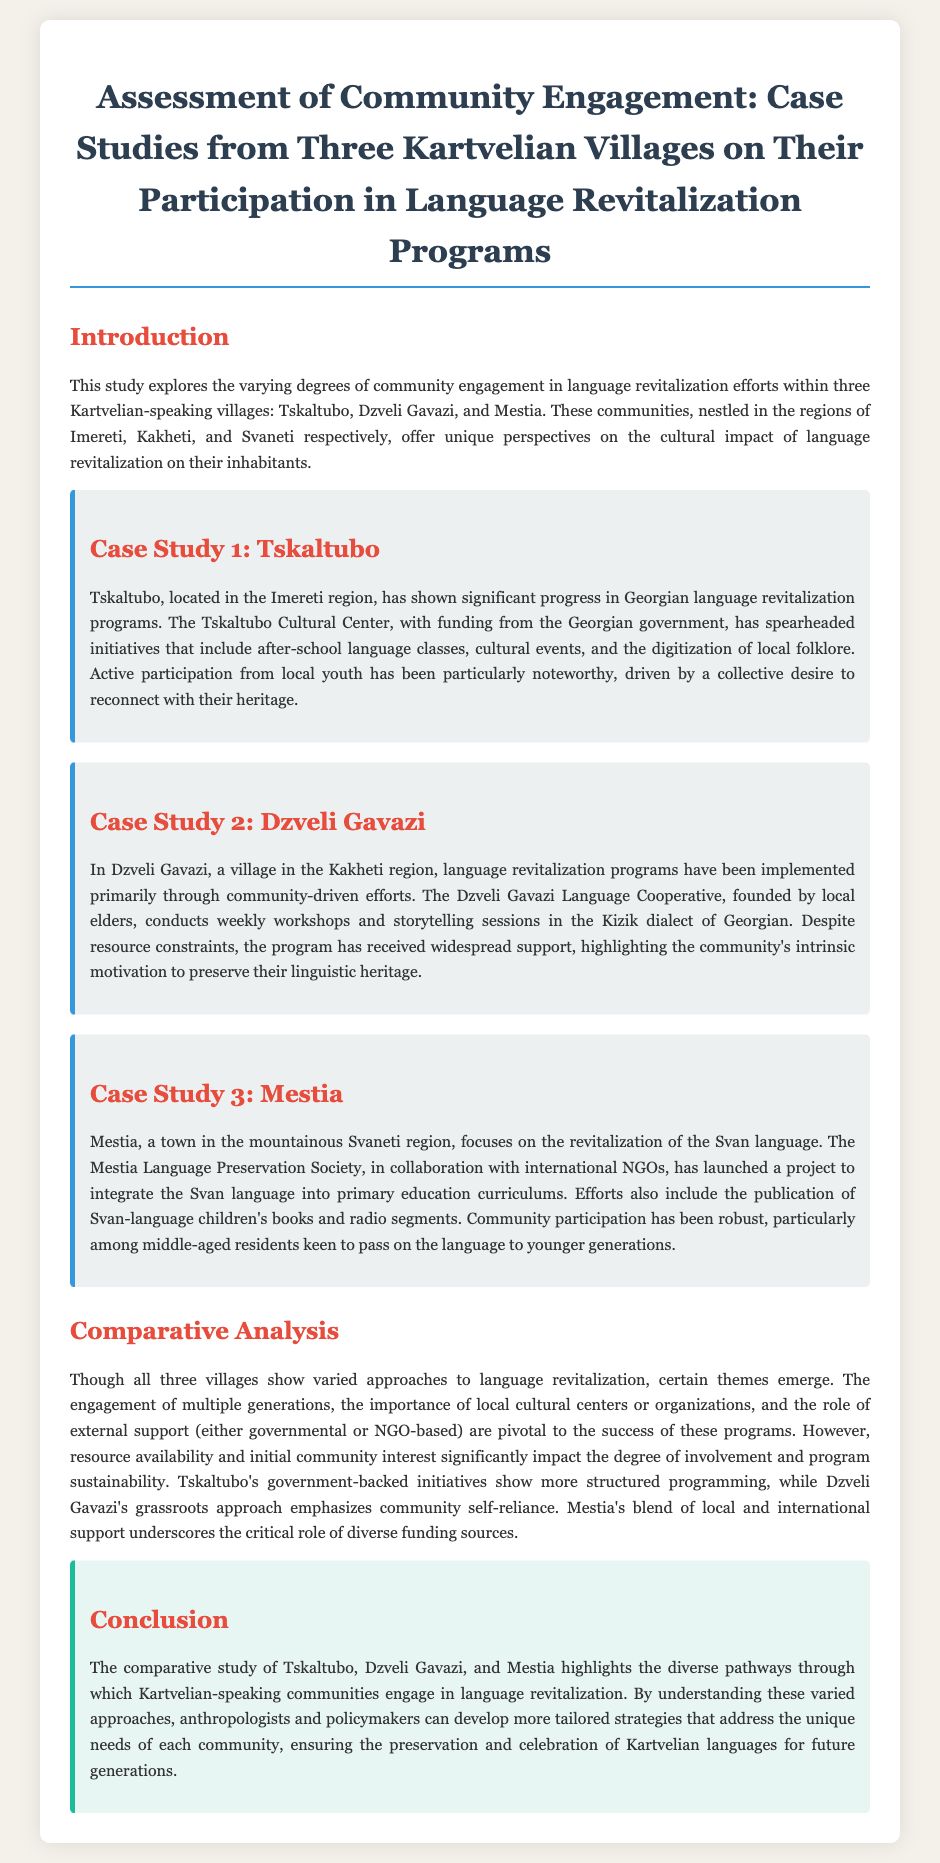What region is Tskaltubo located in? Tskaltubo is specifically mentioned as being in the Imereti region.
Answer: Imereti What organization initiated the language revitalization programs in Tskaltubo? The document indicates that the Tskaltubo Cultural Center has spearheaded the initiatives.
Answer: Tskaltubo Cultural Center Which dialect is preserved in Dzveli Gavazi? The document specifies that the Kizik dialect of Georgian is used in Dzveli Gavazi's programs.
Answer: Kizik How does Mestia's language revitalization effort incorporate education? The document states that the Svan language is integrated into primary education curriculums as part of the efforts.
Answer: Primary education curriculums What type of support does Mestia's program have? The study mentions that Mestia's initiatives are in collaboration with international NGOs.
Answer: International NGOs In terms of community engagement, what significant factor influences program sustainability? The importance of resource availability is highlighted as affecting degrees of involvement and sustainability.
Answer: Resource availability What is a notable characteristic of Tskaltubo's initiatives compared to Dzveli Gavazi's? Tskaltubo's initiatives are described as being government-backed and more structured compared to Dzveli Gavazi's grassroots approach.
Answer: Government-backed initiatives Which generation is particularly active in Mestia's language revitalization efforts? The document notes that middle-aged residents are keen to participate in passing on the language.
Answer: Middle-aged residents 